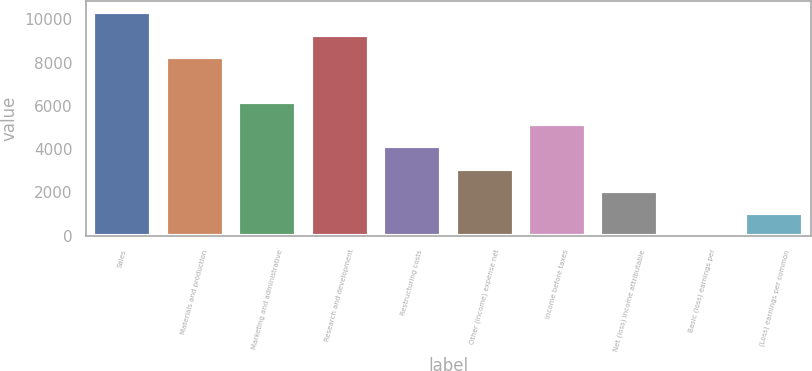<chart> <loc_0><loc_0><loc_500><loc_500><bar_chart><fcel>Sales<fcel>Materials and production<fcel>Marketing and administrative<fcel>Research and development<fcel>Restructuring costs<fcel>Other (income) expense net<fcel>Income before taxes<fcel>Net (loss) income attributable<fcel>Basic (loss) earnings per<fcel>(Loss) earnings per common<nl><fcel>10325<fcel>8260.02<fcel>6195.02<fcel>9292.52<fcel>4130.02<fcel>3097.52<fcel>5162.52<fcel>2065.02<fcel>0.02<fcel>1032.52<nl></chart> 